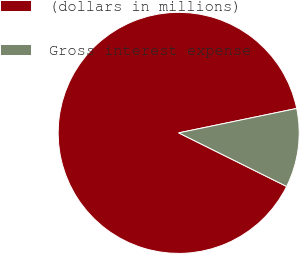Convert chart. <chart><loc_0><loc_0><loc_500><loc_500><pie_chart><fcel>(dollars in millions)<fcel>Gross interest expense<nl><fcel>89.42%<fcel>10.58%<nl></chart> 